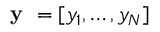Convert formula to latex. <formula><loc_0><loc_0><loc_500><loc_500>y = [ y _ { 1 } , \dots , y _ { N } ]</formula> 